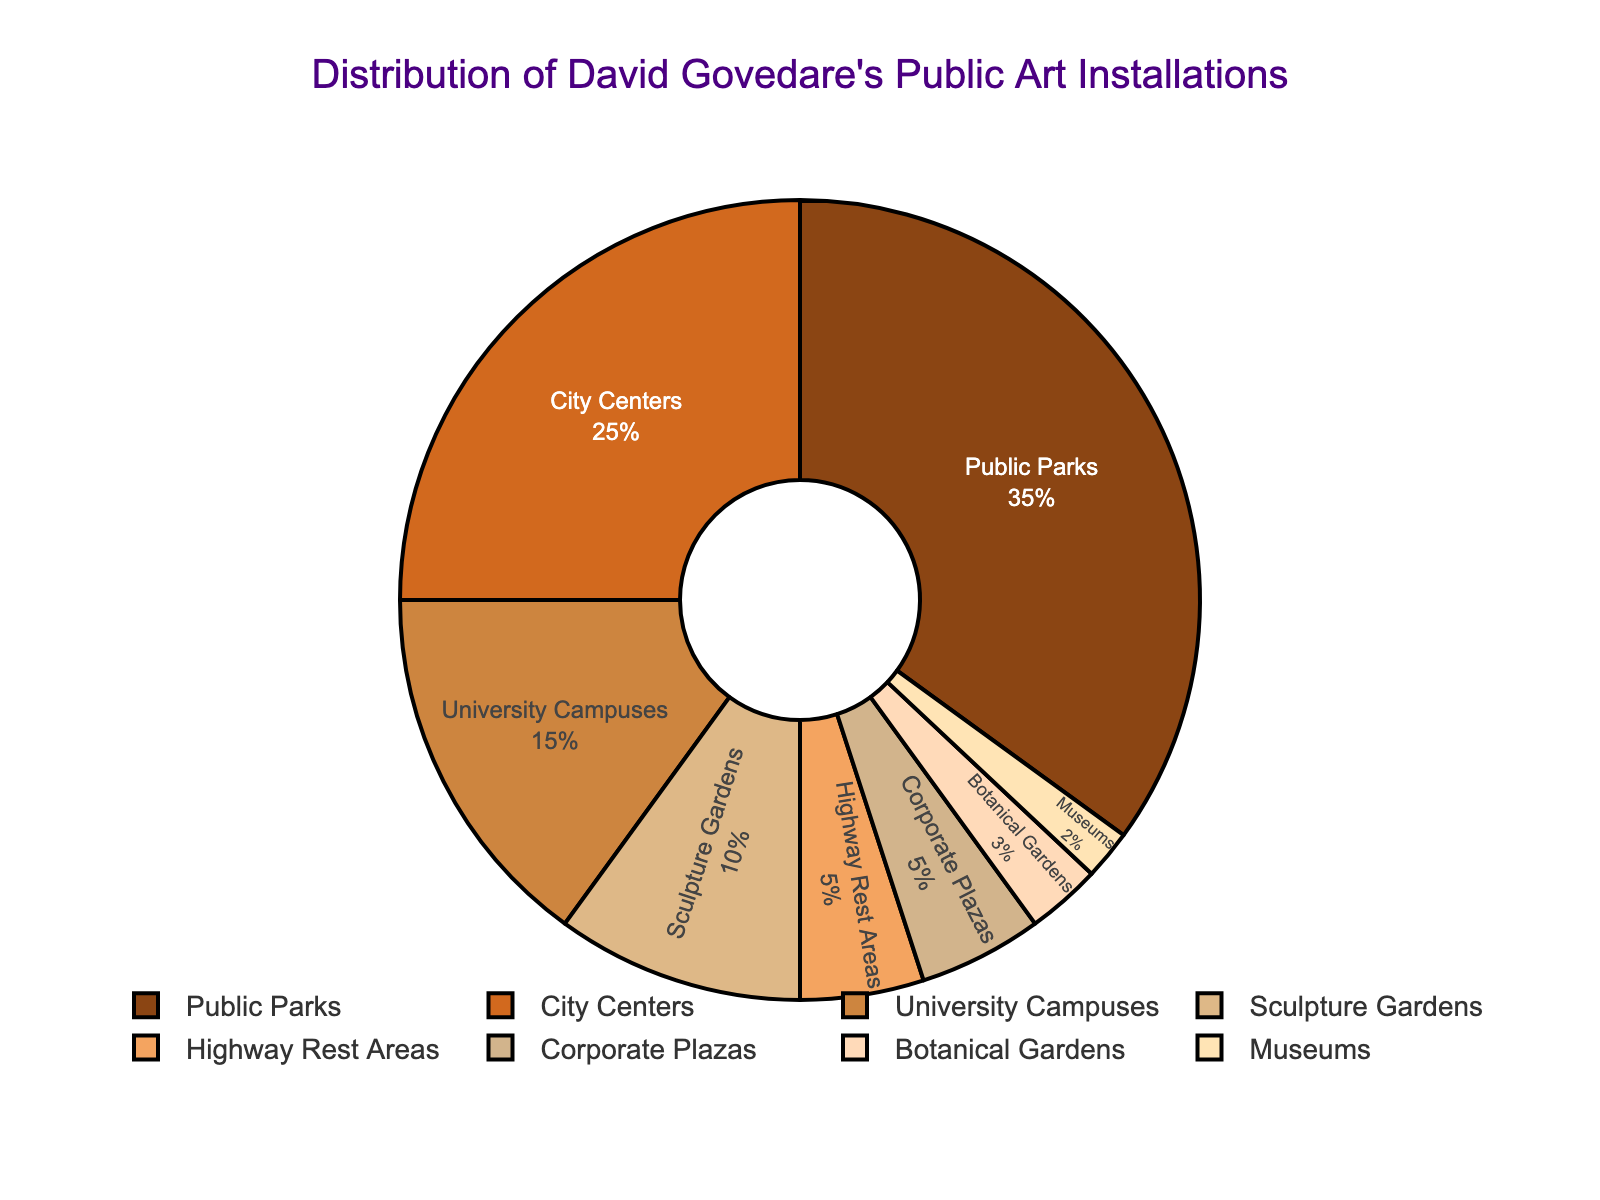Which location type has the largest percentage of David Govedare's public art installations? From the pie chart, the segment labeled "Public Parks" is the largest, which indicates it has the largest percentage.
Answer: Public Parks How much more frequent are David Govedare's installations in Public Parks compared to City Centers? Public Parks have 35% and City Centers have 25%. The difference is 35% - 25% = 10%.
Answer: 10% What is the combined percentage of David Govedare's installations in Corporate Plazas and Highway Rest Areas? Corporate Plazas have 5% and Highway Rest Areas have 5%. The sum is 5% + 5% = 10%.
Answer: 10% Which three location types have the smallest proportions of David Govedare's public art installations? The pie chart shows the smallest segments are Museums (2%), Botanical Gardens (3%), and Highway Rest Areas (5%).
Answer: Museums, Botanical Gardens, Highway Rest Areas What percentage of David Govedare's installations are in educational environments (University Campuses)? The segment labeled "University Campuses" represents 15% of the total.
Answer: 15% What is the combined percentage of David Govedare’s installations in University Campuses and Sculpture Gardens? University Campuses have 15% and Sculpture Gardens have 10%. The sum is 15% + 10% = 25%.
Answer: 25% By how much does the percentage of installations in Public Parks exceed those in Sculpture Gardens? Public Parks have 35% and Sculpture Gardens have 10%. The difference is 35% - 10% = 25%.
Answer: 25% Rank the location types from highest to lowest percentage of David Govedare's installations. From the pie chart, the order is Public Parks (35%), City Centers (25%), University Campuses (15%), Sculpture Gardens (10%), Highway Rest Areas (5%), Corporate Plazas (5%), Botanical Gardens (3%), Museums (2%).
Answer: Public Parks, City Centers, University Campuses, Sculpture Gardens, Highway Rest Areas, Corporate Plazas, Botanical Gardens, Museums If David Govedare adds 2% more installations to Museums, what will be the new percentage for Museums? Museums currently have 2%. Adding 2% more results in 2% + 2% = 4%.
Answer: 4% What is the difference in percentage between the location type with the second-highest number of installations and the location type with the lowest number of installations? The second-highest is City Centers at 25% and the lowest is Museums at 2%. The difference is 25% - 2% = 23%.
Answer: 23% 